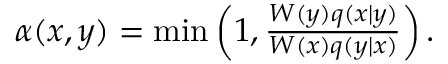<formula> <loc_0><loc_0><loc_500><loc_500>\begin{array} { r } { \alpha ( x , y ) = \min \left ( 1 , \frac { W ( y ) q ( x | y ) } { W ( x ) q ( y | x ) } \right ) . } \end{array}</formula> 